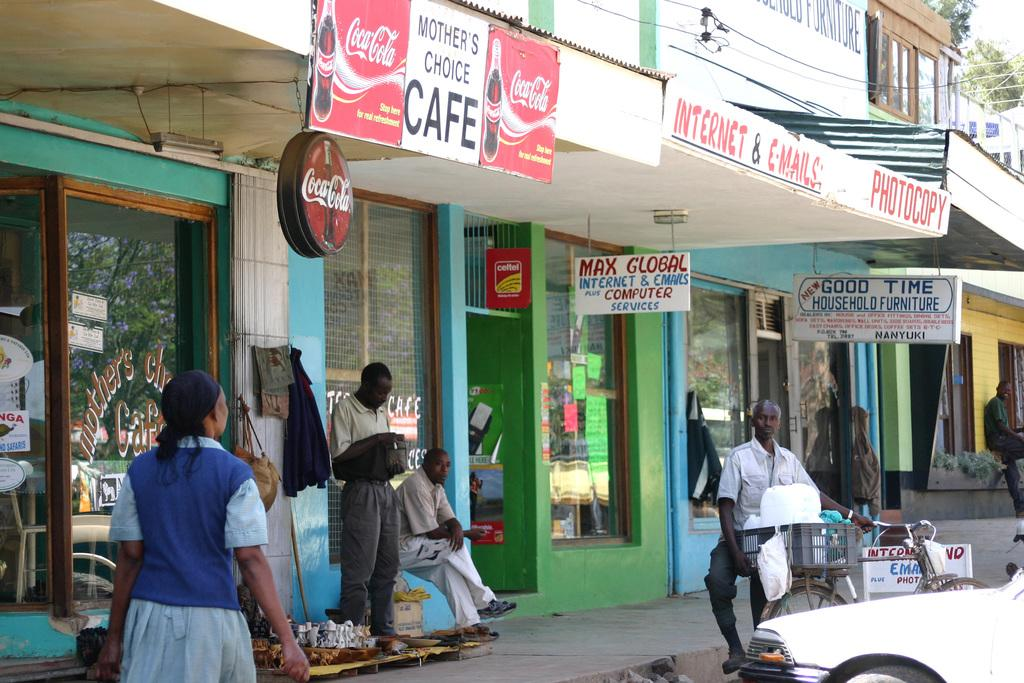<image>
Write a terse but informative summary of the picture. The Mother's Choice Cafe has Coca-Cola ads on it. 